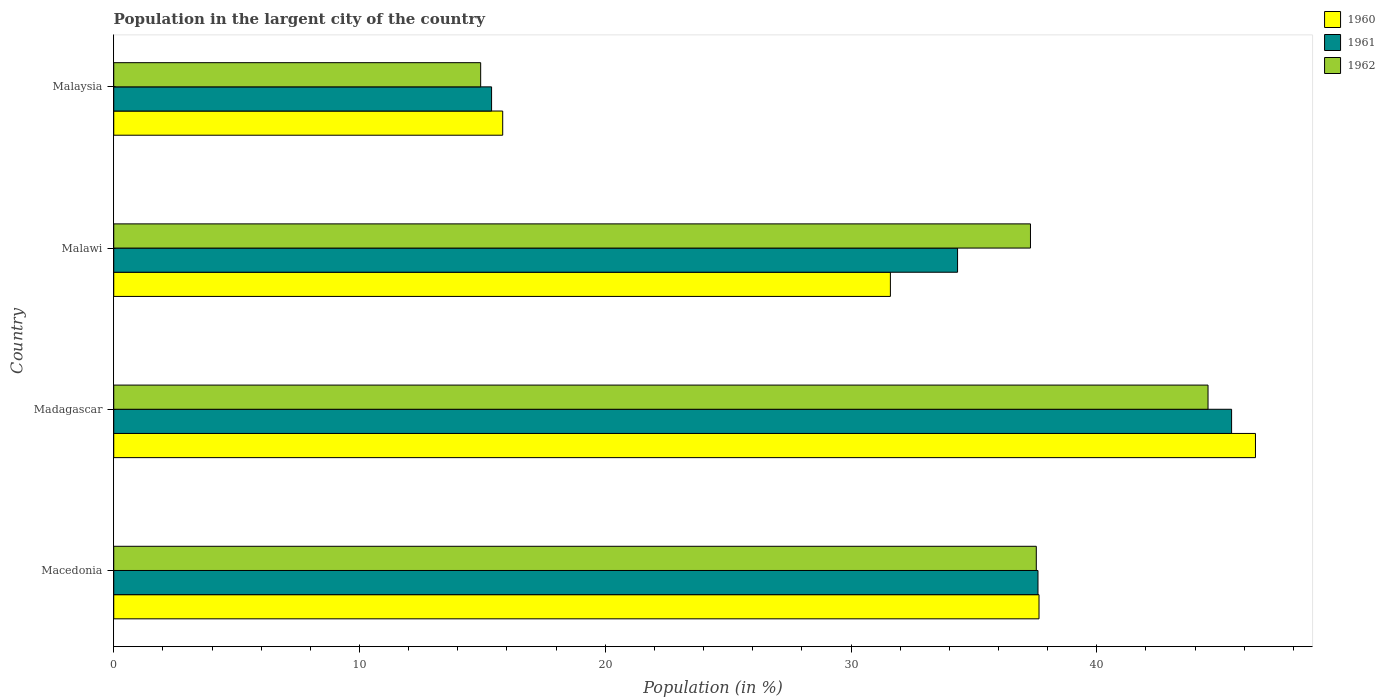How many different coloured bars are there?
Offer a terse response. 3. How many groups of bars are there?
Offer a terse response. 4. Are the number of bars per tick equal to the number of legend labels?
Offer a very short reply. Yes. Are the number of bars on each tick of the Y-axis equal?
Offer a very short reply. Yes. How many bars are there on the 1st tick from the top?
Provide a succinct answer. 3. How many bars are there on the 4th tick from the bottom?
Your response must be concise. 3. What is the label of the 3rd group of bars from the top?
Offer a terse response. Madagascar. In how many cases, is the number of bars for a given country not equal to the number of legend labels?
Your answer should be very brief. 0. What is the percentage of population in the largent city in 1961 in Madagascar?
Make the answer very short. 45.48. Across all countries, what is the maximum percentage of population in the largent city in 1962?
Provide a short and direct response. 44.52. Across all countries, what is the minimum percentage of population in the largent city in 1962?
Your answer should be compact. 14.93. In which country was the percentage of population in the largent city in 1962 maximum?
Provide a succinct answer. Madagascar. In which country was the percentage of population in the largent city in 1960 minimum?
Keep it short and to the point. Malaysia. What is the total percentage of population in the largent city in 1962 in the graph?
Keep it short and to the point. 134.29. What is the difference between the percentage of population in the largent city in 1961 in Malawi and that in Malaysia?
Offer a very short reply. 18.96. What is the difference between the percentage of population in the largent city in 1962 in Malawi and the percentage of population in the largent city in 1961 in Madagascar?
Offer a terse response. -8.18. What is the average percentage of population in the largent city in 1961 per country?
Your response must be concise. 33.2. What is the difference between the percentage of population in the largent city in 1962 and percentage of population in the largent city in 1961 in Madagascar?
Keep it short and to the point. -0.96. In how many countries, is the percentage of population in the largent city in 1960 greater than 40 %?
Give a very brief answer. 1. What is the ratio of the percentage of population in the largent city in 1961 in Madagascar to that in Malawi?
Provide a succinct answer. 1.32. Is the difference between the percentage of population in the largent city in 1962 in Macedonia and Malawi greater than the difference between the percentage of population in the largent city in 1961 in Macedonia and Malawi?
Offer a very short reply. No. What is the difference between the highest and the second highest percentage of population in the largent city in 1961?
Provide a succinct answer. 7.88. What is the difference between the highest and the lowest percentage of population in the largent city in 1961?
Provide a short and direct response. 30.11. In how many countries, is the percentage of population in the largent city in 1961 greater than the average percentage of population in the largent city in 1961 taken over all countries?
Offer a very short reply. 3. Is the sum of the percentage of population in the largent city in 1961 in Macedonia and Madagascar greater than the maximum percentage of population in the largent city in 1960 across all countries?
Your answer should be compact. Yes. What does the 1st bar from the top in Macedonia represents?
Give a very brief answer. 1962. Is it the case that in every country, the sum of the percentage of population in the largent city in 1961 and percentage of population in the largent city in 1960 is greater than the percentage of population in the largent city in 1962?
Your answer should be very brief. Yes. Are all the bars in the graph horizontal?
Give a very brief answer. Yes. What is the difference between two consecutive major ticks on the X-axis?
Ensure brevity in your answer.  10. Where does the legend appear in the graph?
Ensure brevity in your answer.  Top right. How many legend labels are there?
Your answer should be compact. 3. How are the legend labels stacked?
Your answer should be compact. Vertical. What is the title of the graph?
Provide a succinct answer. Population in the largent city of the country. Does "1970" appear as one of the legend labels in the graph?
Provide a short and direct response. No. What is the label or title of the X-axis?
Offer a very short reply. Population (in %). What is the label or title of the Y-axis?
Ensure brevity in your answer.  Country. What is the Population (in %) of 1960 in Macedonia?
Provide a short and direct response. 37.65. What is the Population (in %) in 1961 in Macedonia?
Your answer should be compact. 37.61. What is the Population (in %) in 1962 in Macedonia?
Provide a short and direct response. 37.54. What is the Population (in %) in 1960 in Madagascar?
Ensure brevity in your answer.  46.45. What is the Population (in %) in 1961 in Madagascar?
Offer a very short reply. 45.48. What is the Population (in %) of 1962 in Madagascar?
Your response must be concise. 44.52. What is the Population (in %) of 1960 in Malawi?
Your answer should be very brief. 31.6. What is the Population (in %) of 1961 in Malawi?
Provide a short and direct response. 34.33. What is the Population (in %) in 1962 in Malawi?
Ensure brevity in your answer.  37.3. What is the Population (in %) of 1960 in Malaysia?
Your answer should be compact. 15.83. What is the Population (in %) in 1961 in Malaysia?
Give a very brief answer. 15.37. What is the Population (in %) of 1962 in Malaysia?
Provide a succinct answer. 14.93. Across all countries, what is the maximum Population (in %) of 1960?
Provide a short and direct response. 46.45. Across all countries, what is the maximum Population (in %) of 1961?
Your answer should be very brief. 45.48. Across all countries, what is the maximum Population (in %) of 1962?
Your answer should be compact. 44.52. Across all countries, what is the minimum Population (in %) of 1960?
Offer a terse response. 15.83. Across all countries, what is the minimum Population (in %) in 1961?
Your answer should be compact. 15.37. Across all countries, what is the minimum Population (in %) in 1962?
Keep it short and to the point. 14.93. What is the total Population (in %) of 1960 in the graph?
Offer a very short reply. 131.53. What is the total Population (in %) in 1961 in the graph?
Your answer should be very brief. 132.8. What is the total Population (in %) of 1962 in the graph?
Ensure brevity in your answer.  134.29. What is the difference between the Population (in %) in 1960 in Macedonia and that in Madagascar?
Offer a very short reply. -8.81. What is the difference between the Population (in %) of 1961 in Macedonia and that in Madagascar?
Provide a short and direct response. -7.88. What is the difference between the Population (in %) of 1962 in Macedonia and that in Madagascar?
Your answer should be very brief. -6.99. What is the difference between the Population (in %) in 1960 in Macedonia and that in Malawi?
Give a very brief answer. 6.05. What is the difference between the Population (in %) of 1961 in Macedonia and that in Malawi?
Your answer should be very brief. 3.27. What is the difference between the Population (in %) in 1962 in Macedonia and that in Malawi?
Offer a very short reply. 0.24. What is the difference between the Population (in %) of 1960 in Macedonia and that in Malaysia?
Provide a succinct answer. 21.82. What is the difference between the Population (in %) in 1961 in Macedonia and that in Malaysia?
Your answer should be compact. 22.23. What is the difference between the Population (in %) in 1962 in Macedonia and that in Malaysia?
Your answer should be compact. 22.61. What is the difference between the Population (in %) in 1960 in Madagascar and that in Malawi?
Give a very brief answer. 14.85. What is the difference between the Population (in %) of 1961 in Madagascar and that in Malawi?
Your answer should be very brief. 11.15. What is the difference between the Population (in %) in 1962 in Madagascar and that in Malawi?
Make the answer very short. 7.22. What is the difference between the Population (in %) in 1960 in Madagascar and that in Malaysia?
Your answer should be very brief. 30.63. What is the difference between the Population (in %) in 1961 in Madagascar and that in Malaysia?
Offer a very short reply. 30.11. What is the difference between the Population (in %) in 1962 in Madagascar and that in Malaysia?
Make the answer very short. 29.59. What is the difference between the Population (in %) in 1960 in Malawi and that in Malaysia?
Provide a short and direct response. 15.77. What is the difference between the Population (in %) in 1961 in Malawi and that in Malaysia?
Give a very brief answer. 18.96. What is the difference between the Population (in %) of 1962 in Malawi and that in Malaysia?
Your response must be concise. 22.37. What is the difference between the Population (in %) of 1960 in Macedonia and the Population (in %) of 1961 in Madagascar?
Give a very brief answer. -7.84. What is the difference between the Population (in %) in 1960 in Macedonia and the Population (in %) in 1962 in Madagascar?
Keep it short and to the point. -6.88. What is the difference between the Population (in %) of 1961 in Macedonia and the Population (in %) of 1962 in Madagascar?
Ensure brevity in your answer.  -6.92. What is the difference between the Population (in %) in 1960 in Macedonia and the Population (in %) in 1961 in Malawi?
Your response must be concise. 3.31. What is the difference between the Population (in %) of 1960 in Macedonia and the Population (in %) of 1962 in Malawi?
Keep it short and to the point. 0.35. What is the difference between the Population (in %) in 1961 in Macedonia and the Population (in %) in 1962 in Malawi?
Keep it short and to the point. 0.31. What is the difference between the Population (in %) in 1960 in Macedonia and the Population (in %) in 1961 in Malaysia?
Provide a short and direct response. 22.27. What is the difference between the Population (in %) of 1960 in Macedonia and the Population (in %) of 1962 in Malaysia?
Provide a short and direct response. 22.72. What is the difference between the Population (in %) of 1961 in Macedonia and the Population (in %) of 1962 in Malaysia?
Provide a short and direct response. 22.68. What is the difference between the Population (in %) in 1960 in Madagascar and the Population (in %) in 1961 in Malawi?
Keep it short and to the point. 12.12. What is the difference between the Population (in %) in 1960 in Madagascar and the Population (in %) in 1962 in Malawi?
Your answer should be compact. 9.15. What is the difference between the Population (in %) in 1961 in Madagascar and the Population (in %) in 1962 in Malawi?
Offer a very short reply. 8.18. What is the difference between the Population (in %) in 1960 in Madagascar and the Population (in %) in 1961 in Malaysia?
Your response must be concise. 31.08. What is the difference between the Population (in %) of 1960 in Madagascar and the Population (in %) of 1962 in Malaysia?
Provide a short and direct response. 31.52. What is the difference between the Population (in %) in 1961 in Madagascar and the Population (in %) in 1962 in Malaysia?
Your answer should be very brief. 30.55. What is the difference between the Population (in %) in 1960 in Malawi and the Population (in %) in 1961 in Malaysia?
Keep it short and to the point. 16.23. What is the difference between the Population (in %) in 1960 in Malawi and the Population (in %) in 1962 in Malaysia?
Ensure brevity in your answer.  16.67. What is the difference between the Population (in %) in 1961 in Malawi and the Population (in %) in 1962 in Malaysia?
Your answer should be compact. 19.4. What is the average Population (in %) of 1960 per country?
Make the answer very short. 32.88. What is the average Population (in %) of 1961 per country?
Offer a terse response. 33.2. What is the average Population (in %) in 1962 per country?
Your response must be concise. 33.57. What is the difference between the Population (in %) of 1960 and Population (in %) of 1961 in Macedonia?
Ensure brevity in your answer.  0.04. What is the difference between the Population (in %) of 1960 and Population (in %) of 1962 in Macedonia?
Your response must be concise. 0.11. What is the difference between the Population (in %) in 1961 and Population (in %) in 1962 in Macedonia?
Your answer should be compact. 0.07. What is the difference between the Population (in %) of 1960 and Population (in %) of 1961 in Madagascar?
Ensure brevity in your answer.  0.97. What is the difference between the Population (in %) of 1960 and Population (in %) of 1962 in Madagascar?
Offer a very short reply. 1.93. What is the difference between the Population (in %) in 1961 and Population (in %) in 1962 in Madagascar?
Ensure brevity in your answer.  0.96. What is the difference between the Population (in %) in 1960 and Population (in %) in 1961 in Malawi?
Your answer should be compact. -2.73. What is the difference between the Population (in %) in 1960 and Population (in %) in 1962 in Malawi?
Your response must be concise. -5.7. What is the difference between the Population (in %) of 1961 and Population (in %) of 1962 in Malawi?
Make the answer very short. -2.97. What is the difference between the Population (in %) of 1960 and Population (in %) of 1961 in Malaysia?
Give a very brief answer. 0.45. What is the difference between the Population (in %) in 1960 and Population (in %) in 1962 in Malaysia?
Offer a terse response. 0.9. What is the difference between the Population (in %) of 1961 and Population (in %) of 1962 in Malaysia?
Provide a succinct answer. 0.44. What is the ratio of the Population (in %) of 1960 in Macedonia to that in Madagascar?
Give a very brief answer. 0.81. What is the ratio of the Population (in %) of 1961 in Macedonia to that in Madagascar?
Keep it short and to the point. 0.83. What is the ratio of the Population (in %) of 1962 in Macedonia to that in Madagascar?
Your answer should be very brief. 0.84. What is the ratio of the Population (in %) of 1960 in Macedonia to that in Malawi?
Your response must be concise. 1.19. What is the ratio of the Population (in %) of 1961 in Macedonia to that in Malawi?
Make the answer very short. 1.1. What is the ratio of the Population (in %) in 1960 in Macedonia to that in Malaysia?
Your response must be concise. 2.38. What is the ratio of the Population (in %) in 1961 in Macedonia to that in Malaysia?
Keep it short and to the point. 2.45. What is the ratio of the Population (in %) in 1962 in Macedonia to that in Malaysia?
Provide a short and direct response. 2.51. What is the ratio of the Population (in %) in 1960 in Madagascar to that in Malawi?
Give a very brief answer. 1.47. What is the ratio of the Population (in %) in 1961 in Madagascar to that in Malawi?
Offer a very short reply. 1.32. What is the ratio of the Population (in %) in 1962 in Madagascar to that in Malawi?
Give a very brief answer. 1.19. What is the ratio of the Population (in %) of 1960 in Madagascar to that in Malaysia?
Offer a terse response. 2.94. What is the ratio of the Population (in %) of 1961 in Madagascar to that in Malaysia?
Provide a short and direct response. 2.96. What is the ratio of the Population (in %) in 1962 in Madagascar to that in Malaysia?
Your answer should be very brief. 2.98. What is the ratio of the Population (in %) in 1960 in Malawi to that in Malaysia?
Provide a succinct answer. 2. What is the ratio of the Population (in %) of 1961 in Malawi to that in Malaysia?
Ensure brevity in your answer.  2.23. What is the ratio of the Population (in %) of 1962 in Malawi to that in Malaysia?
Give a very brief answer. 2.5. What is the difference between the highest and the second highest Population (in %) in 1960?
Keep it short and to the point. 8.81. What is the difference between the highest and the second highest Population (in %) of 1961?
Offer a terse response. 7.88. What is the difference between the highest and the second highest Population (in %) in 1962?
Provide a succinct answer. 6.99. What is the difference between the highest and the lowest Population (in %) of 1960?
Make the answer very short. 30.63. What is the difference between the highest and the lowest Population (in %) in 1961?
Ensure brevity in your answer.  30.11. What is the difference between the highest and the lowest Population (in %) in 1962?
Offer a terse response. 29.59. 